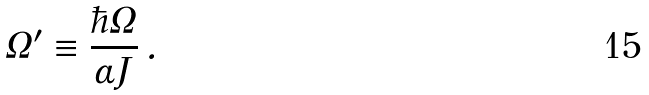Convert formula to latex. <formula><loc_0><loc_0><loc_500><loc_500>\Omega ^ { \prime } \equiv \frac { \hbar { \Omega } } { \alpha J } \, .</formula> 